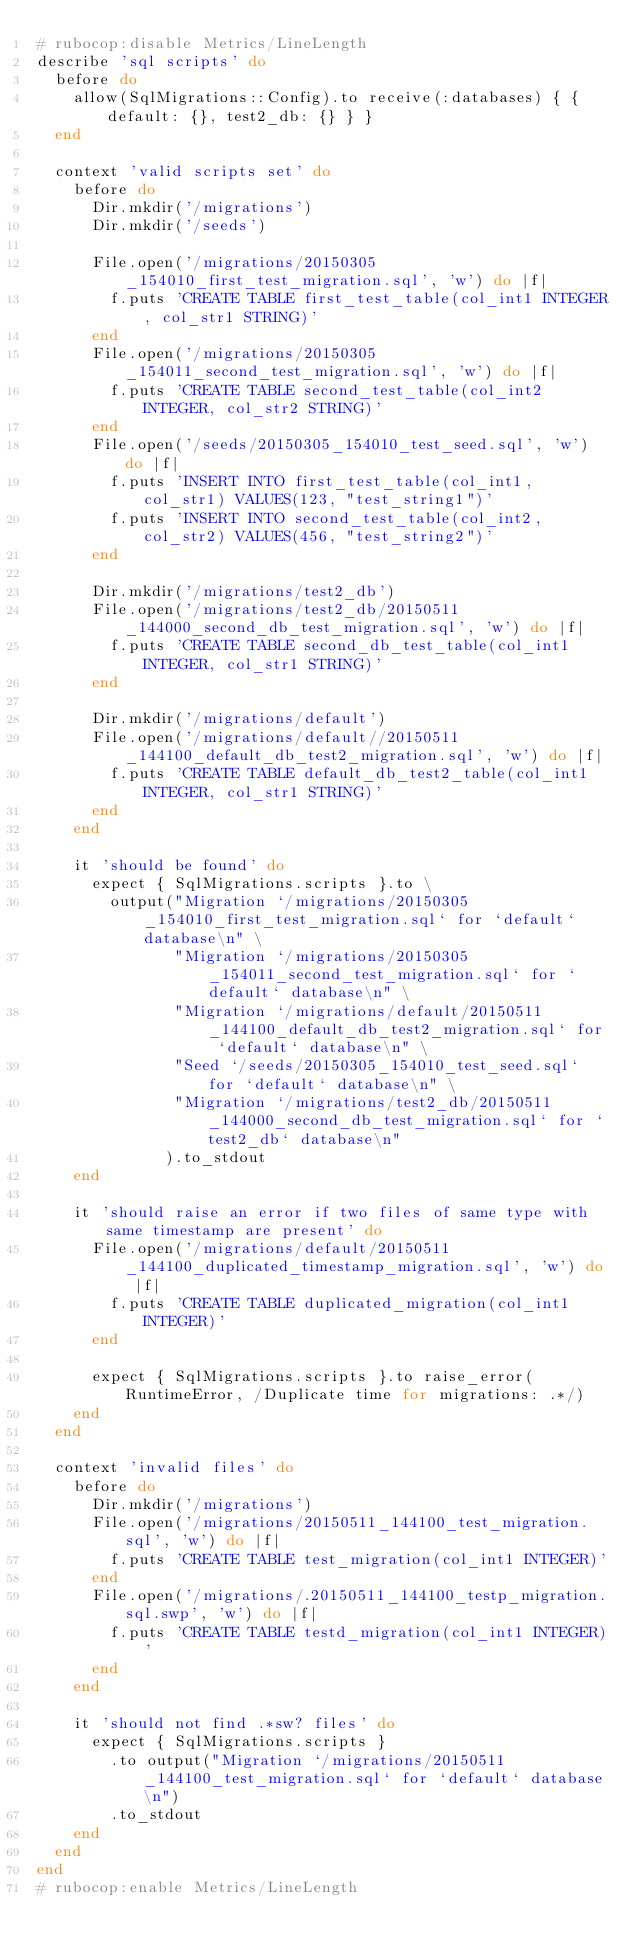Convert code to text. <code><loc_0><loc_0><loc_500><loc_500><_Ruby_># rubocop:disable Metrics/LineLength
describe 'sql scripts' do
  before do
    allow(SqlMigrations::Config).to receive(:databases) { { default: {}, test2_db: {} } }
  end

  context 'valid scripts set' do
    before do
      Dir.mkdir('/migrations')
      Dir.mkdir('/seeds')

      File.open('/migrations/20150305_154010_first_test_migration.sql', 'w') do |f|
        f.puts 'CREATE TABLE first_test_table(col_int1 INTEGER, col_str1 STRING)'
      end
      File.open('/migrations/20150305_154011_second_test_migration.sql', 'w') do |f|
        f.puts 'CREATE TABLE second_test_table(col_int2 INTEGER, col_str2 STRING)'
      end
      File.open('/seeds/20150305_154010_test_seed.sql', 'w') do |f|
        f.puts 'INSERT INTO first_test_table(col_int1, col_str1) VALUES(123, "test_string1")'
        f.puts 'INSERT INTO second_test_table(col_int2, col_str2) VALUES(456, "test_string2")'
      end

      Dir.mkdir('/migrations/test2_db')
      File.open('/migrations/test2_db/20150511_144000_second_db_test_migration.sql', 'w') do |f|
        f.puts 'CREATE TABLE second_db_test_table(col_int1 INTEGER, col_str1 STRING)'
      end

      Dir.mkdir('/migrations/default')
      File.open('/migrations/default//20150511_144100_default_db_test2_migration.sql', 'w') do |f|
        f.puts 'CREATE TABLE default_db_test2_table(col_int1 INTEGER, col_str1 STRING)'
      end
    end

    it 'should be found' do
      expect { SqlMigrations.scripts }.to \
        output("Migration `/migrations/20150305_154010_first_test_migration.sql` for `default` database\n" \
               "Migration `/migrations/20150305_154011_second_test_migration.sql` for `default` database\n" \
               "Migration `/migrations/default/20150511_144100_default_db_test2_migration.sql` for `default` database\n" \
               "Seed `/seeds/20150305_154010_test_seed.sql` for `default` database\n" \
               "Migration `/migrations/test2_db/20150511_144000_second_db_test_migration.sql` for `test2_db` database\n"
              ).to_stdout
    end

    it 'should raise an error if two files of same type with same timestamp are present' do
      File.open('/migrations/default/20150511_144100_duplicated_timestamp_migration.sql', 'w') do |f|
        f.puts 'CREATE TABLE duplicated_migration(col_int1 INTEGER)'
      end

      expect { SqlMigrations.scripts }.to raise_error(RuntimeError, /Duplicate time for migrations: .*/)
    end
  end

  context 'invalid files' do
    before do
      Dir.mkdir('/migrations')
      File.open('/migrations/20150511_144100_test_migration.sql', 'w') do |f|
        f.puts 'CREATE TABLE test_migration(col_int1 INTEGER)'
      end
      File.open('/migrations/.20150511_144100_testp_migration.sql.swp', 'w') do |f|
        f.puts 'CREATE TABLE testd_migration(col_int1 INTEGER)'
      end
    end

    it 'should not find .*sw? files' do
      expect { SqlMigrations.scripts }
        .to output("Migration `/migrations/20150511_144100_test_migration.sql` for `default` database\n")
        .to_stdout
    end
  end
end
# rubocop:enable Metrics/LineLength
</code> 